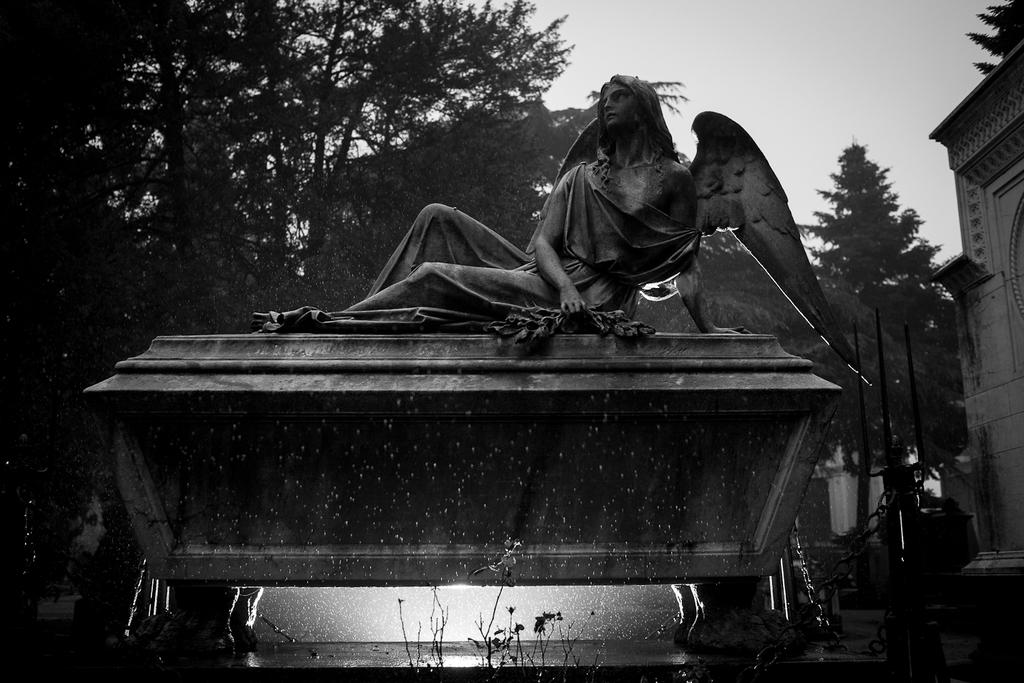What is the main subject of the image? There is a statue of a woman with wings in the image. How is the statue positioned in the image? The statue is leaning on a stone. What can be seen in the background of the image? There are trees, the sky, a building, and a pole in the background of the image. What is attached to the stone the statue is leaning on? Chains are attached to the stone the statue is leaning on. What is the distance between the statue's fangs in the image? The statue does not have fangs, as it is a statue of a woman with wings. 